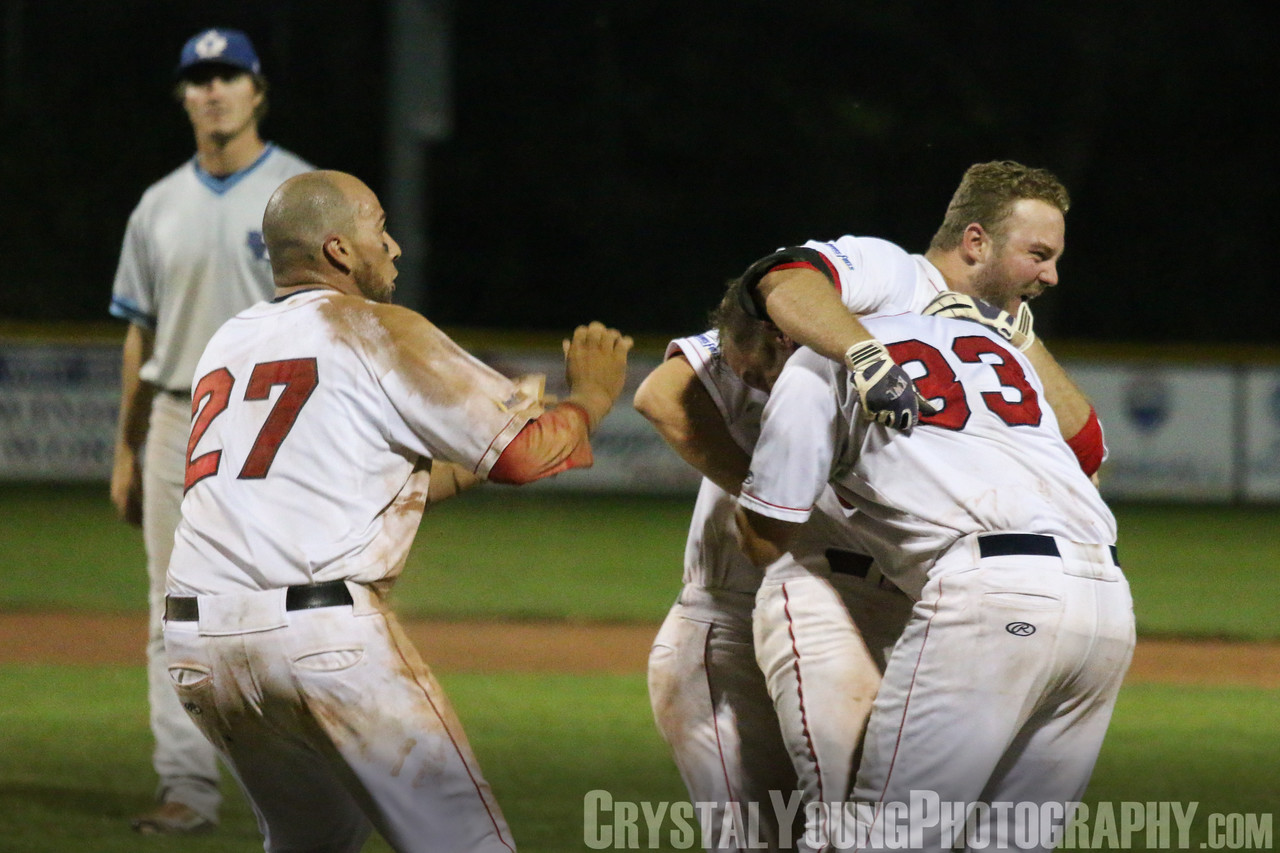Imagine this image was part of a movie scene. Describe the scene that led to this moment. In a tense, climactic scene of a sports drama film, the home team, trailing by just one run in the final inning, makes its last stand. The crowd is on the edge of their seats as the batter steps up to the plate. With two outs and runners on second and third, the pressure is immense. The pitcher winds up and delivers a fastball, but the batter connects solidly, sending the ball soaring into the outfield. The runners sprint home, and as the winning run crosses the plate, a wave of ecstatic realization sweeps over the team. They immediately rush onto the field, embracing each other in a moment of pure euphoria, captured perfectly in this image. In the background, the camera pans to the opposing team's player, capturing the heartbreak of defeat, adding depth to the scene. 